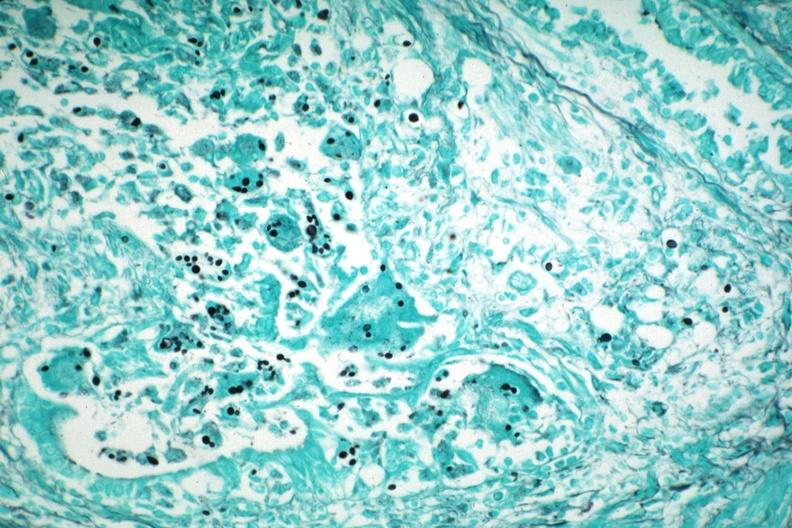does this image show gms illustrates organisms granulomatous prostatitis aids case?
Answer the question using a single word or phrase. Yes 